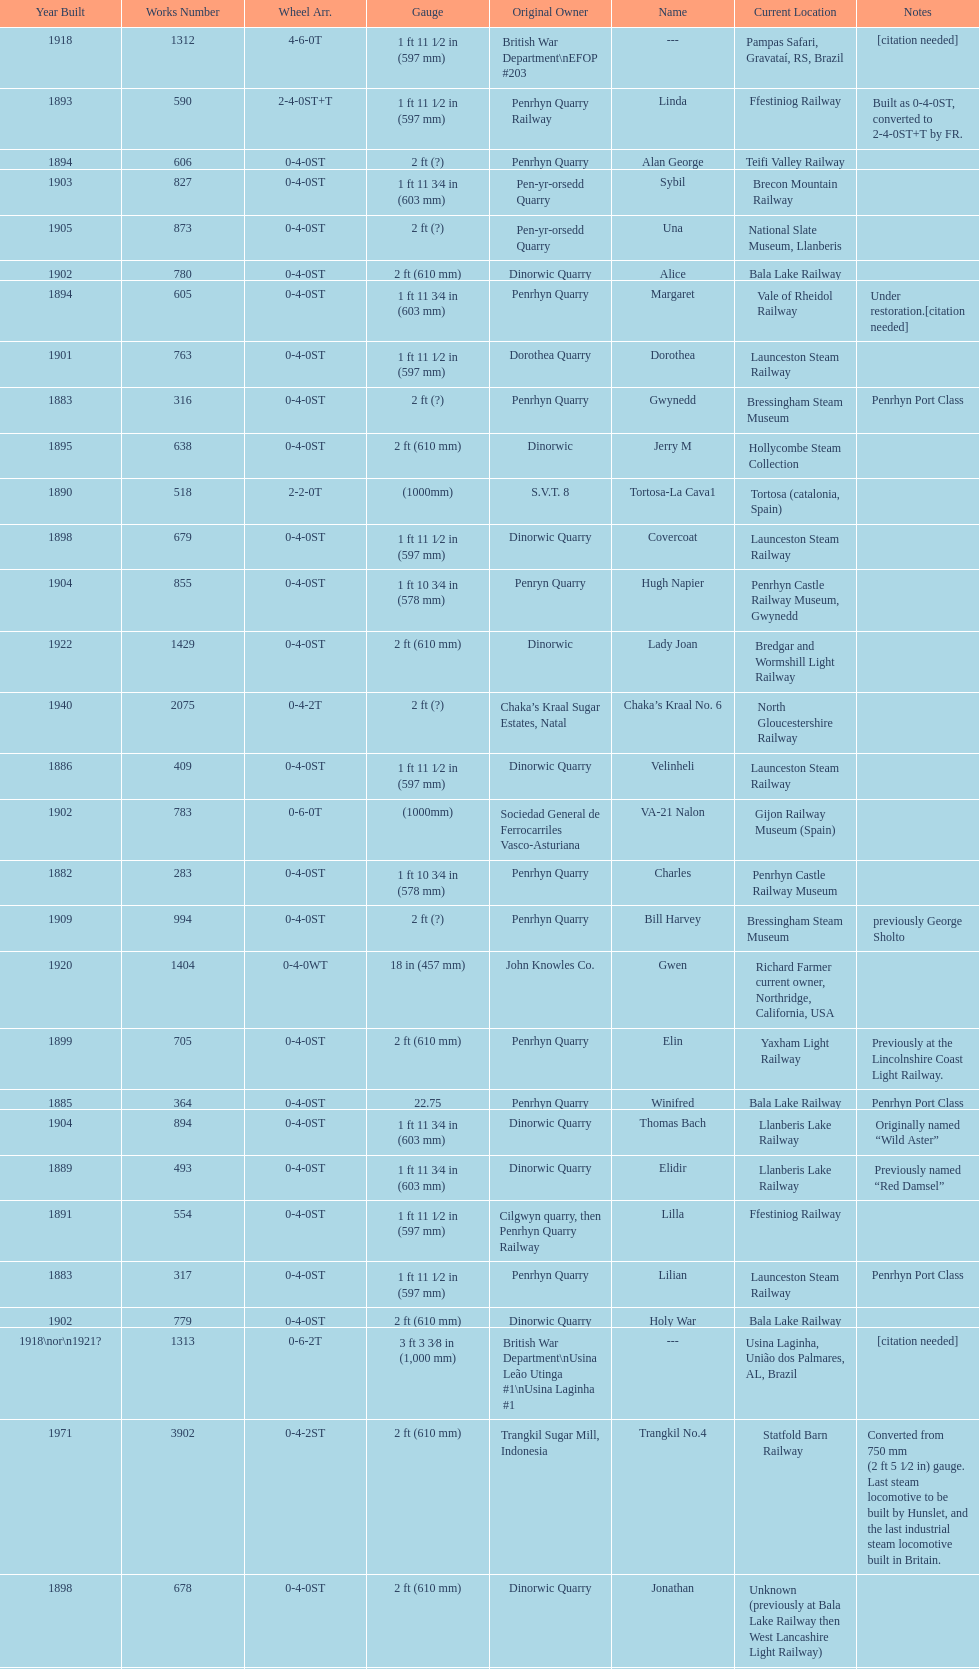What is the works number of the only item built in 1882? 283. 